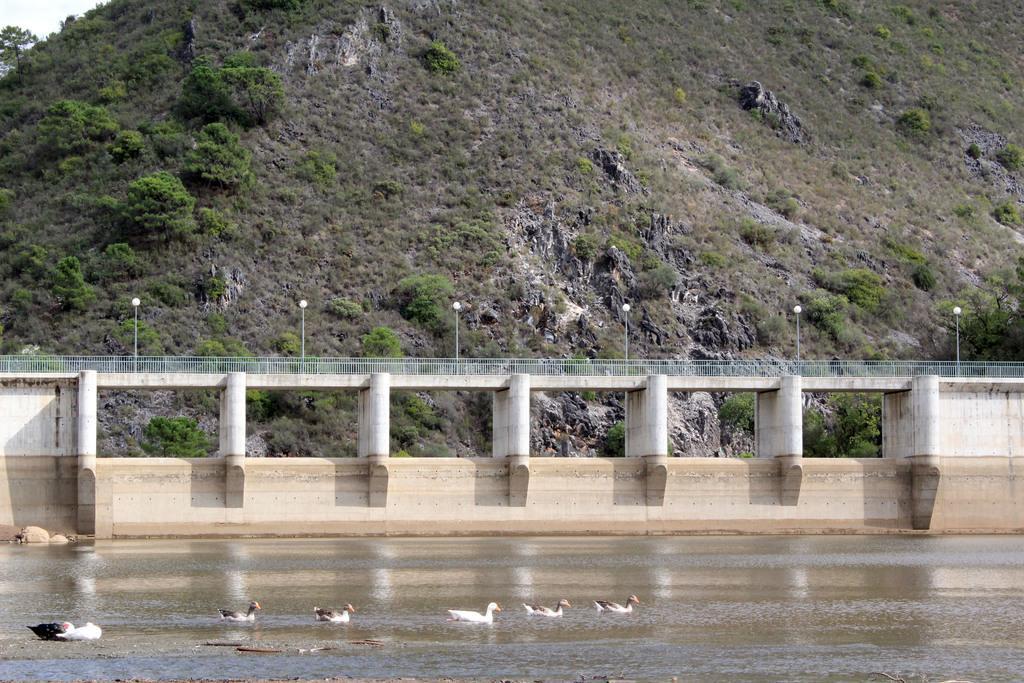Describe this image in one or two sentences. In the center of the image we can see a bridge, railing, poles, lights, wall, pillars. In the background of the image we can see the hill, trees. In the top left corner we can see the sky. At the bottom of the image we can see the ducks in the water. 